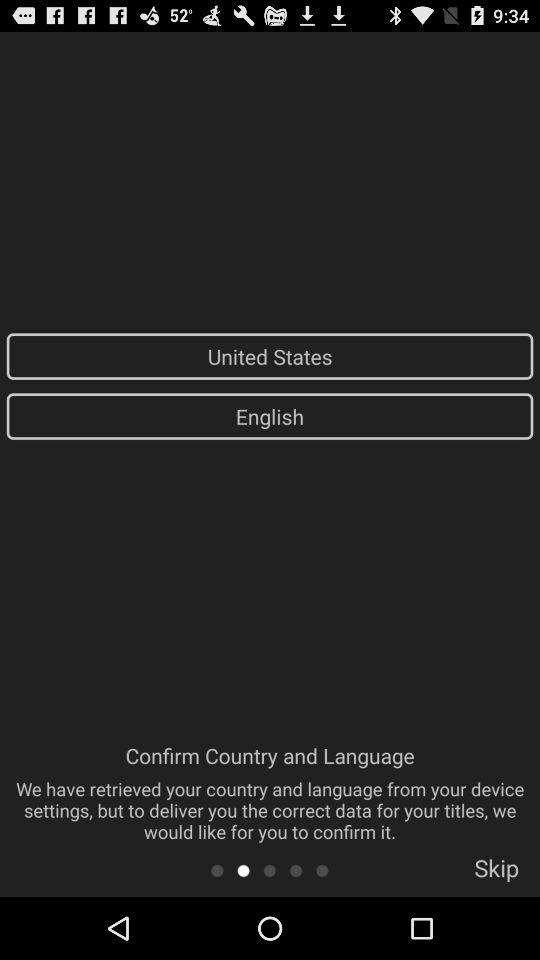What is the selected language? The selected language is English. 